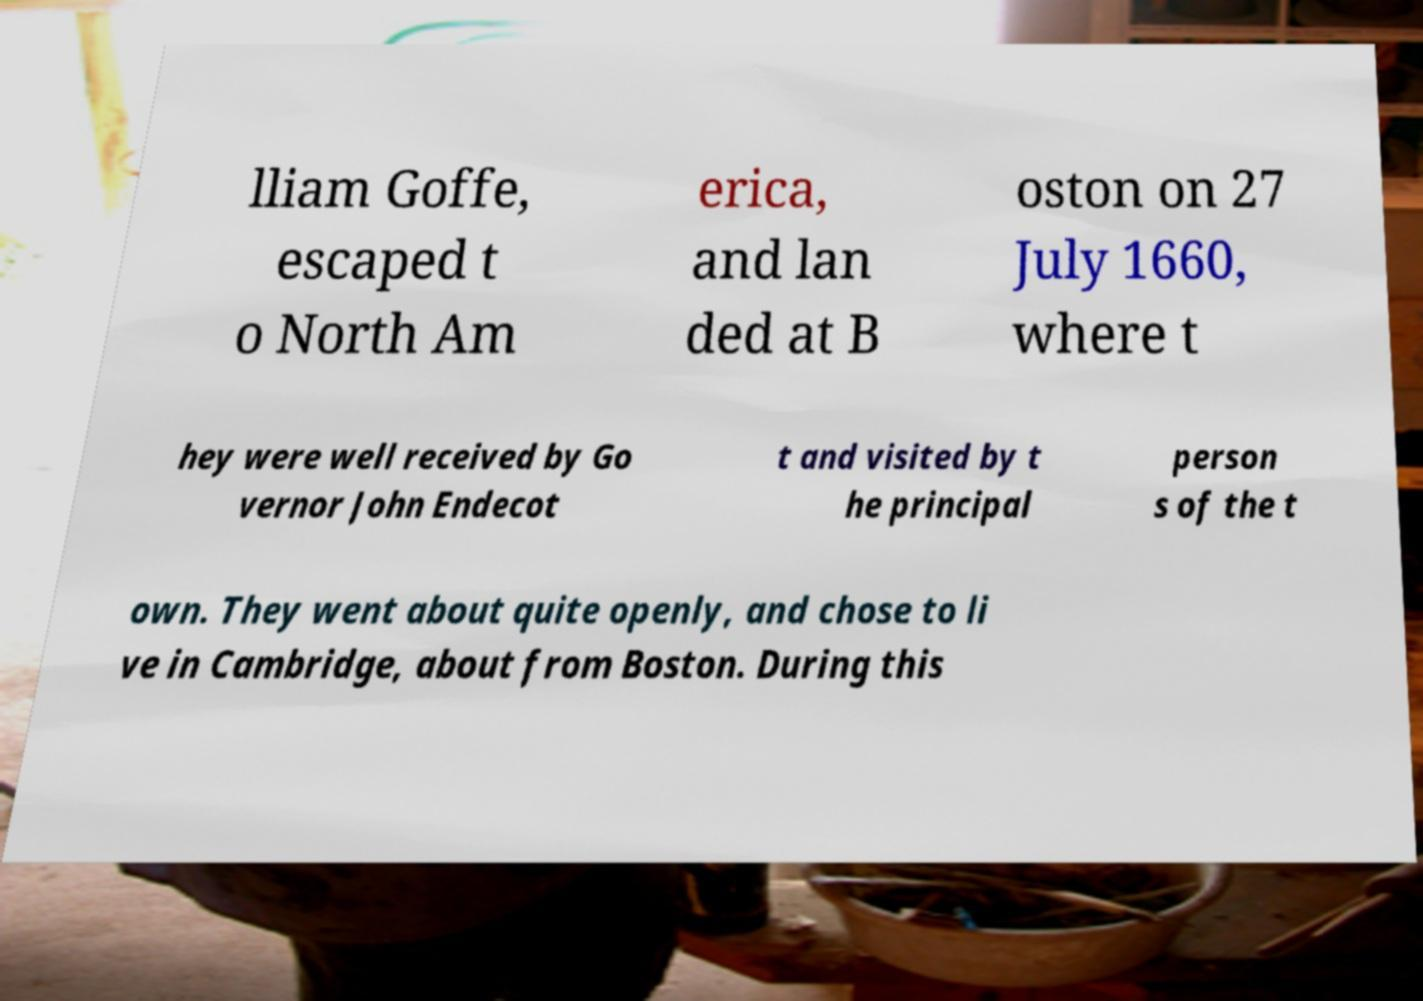Can you accurately transcribe the text from the provided image for me? lliam Goffe, escaped t o North Am erica, and lan ded at B oston on 27 July 1660, where t hey were well received by Go vernor John Endecot t and visited by t he principal person s of the t own. They went about quite openly, and chose to li ve in Cambridge, about from Boston. During this 